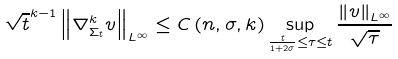Convert formula to latex. <formula><loc_0><loc_0><loc_500><loc_500>\sqrt { t } ^ { k - 1 } \left \| \nabla _ { \Sigma _ { t } } ^ { k } v \right \| _ { L ^ { \infty } } \leq C \left ( n , \sigma , k \right ) \sup _ { \frac { t } { 1 + 2 \sigma } \leq \tau \leq t } \frac { \left \| v \right \| _ { L ^ { \infty } } } { \sqrt { \tau } }</formula> 